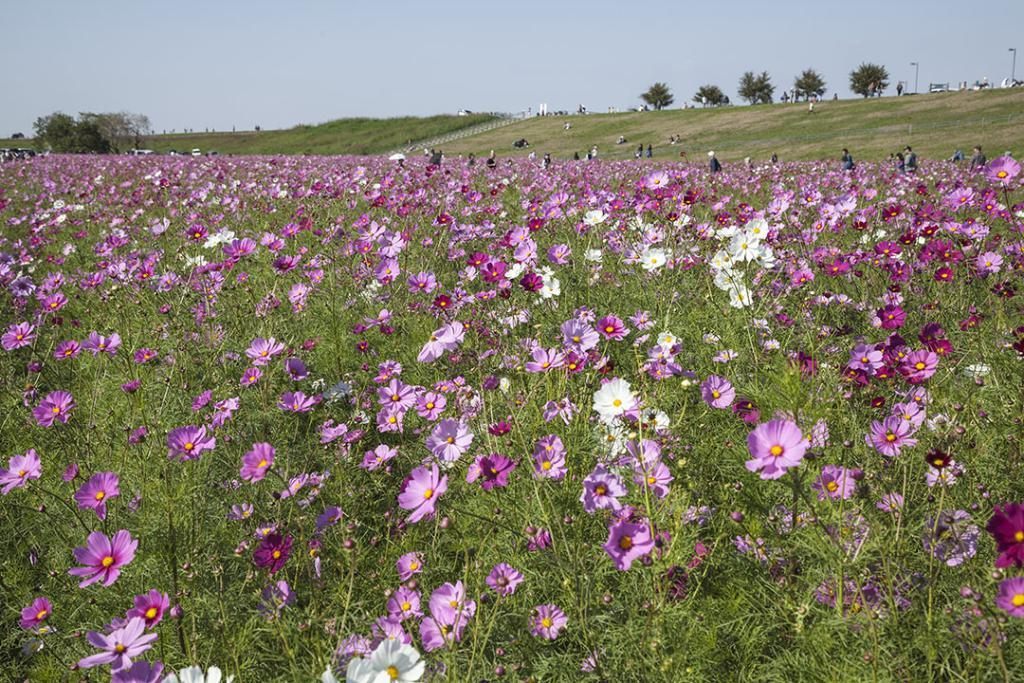What type of flowers can be seen in the image? There are purple flowers in the image. What is on the ground in the image? There is grass on the ground in the image. Where are the trees located in the image? The trees are on the right side top of the image. What type of lighting is present in the image? There are street lights in the image. What can be seen in the sky in the image? The sky is visible in the image. Is there a volcano visible in the image? No, there is no volcano present in the image. Can you see a cobweb hanging from the trees in the image? No, there is no cobweb visible in the image. 